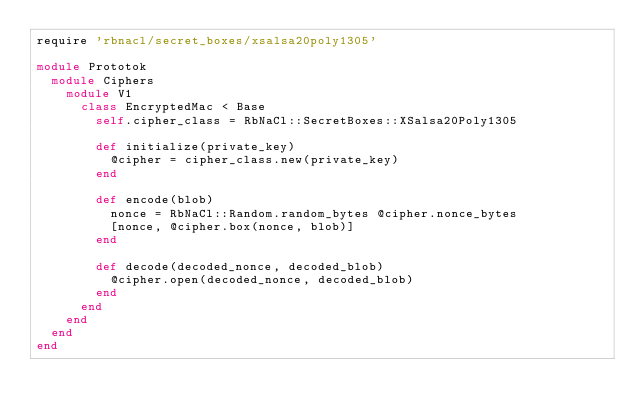Convert code to text. <code><loc_0><loc_0><loc_500><loc_500><_Ruby_>require 'rbnacl/secret_boxes/xsalsa20poly1305'

module Prototok
  module Ciphers
    module V1
      class EncryptedMac < Base
        self.cipher_class = RbNaCl::SecretBoxes::XSalsa20Poly1305

        def initialize(private_key)
          @cipher = cipher_class.new(private_key)
        end

        def encode(blob)
          nonce = RbNaCl::Random.random_bytes @cipher.nonce_bytes
          [nonce, @cipher.box(nonce, blob)]
        end

        def decode(decoded_nonce, decoded_blob)
          @cipher.open(decoded_nonce, decoded_blob)
        end
      end
    end
  end
end
</code> 